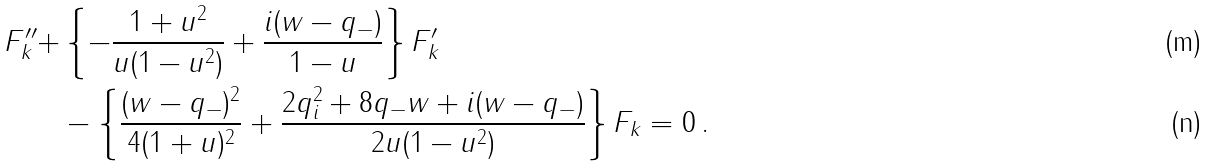Convert formula to latex. <formula><loc_0><loc_0><loc_500><loc_500>F _ { k } ^ { \prime \prime } + & \left \{ - \frac { 1 + u ^ { 2 } } { u ( 1 - u ^ { 2 } ) } + \frac { i ( w - q _ { - } ) } { 1 - u } \right \} F _ { k } ^ { \prime } \\ & - \left \{ \frac { ( w - q _ { - } ) ^ { 2 } } { 4 ( 1 + u ) ^ { 2 } } + \frac { 2 q _ { i } ^ { 2 } + 8 q _ { - } w + i ( w - q _ { - } ) } { 2 u ( 1 - u ^ { 2 } ) } \right \} F _ { k } = 0 \, .</formula> 